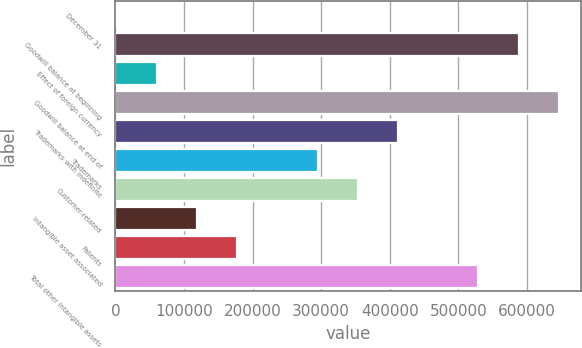<chart> <loc_0><loc_0><loc_500><loc_500><bar_chart><fcel>December 31<fcel>Goodwill balance at beginning<fcel>Effect of foreign currency<fcel>Goodwill balance at end of<fcel>Trademarks with indefinite<fcel>Trademarks<fcel>Customer-related<fcel>Intangible asset associated<fcel>Patents<fcel>Total other intangible assets<nl><fcel>2012<fcel>588003<fcel>60611.1<fcel>646602<fcel>412206<fcel>295008<fcel>353607<fcel>119210<fcel>177809<fcel>529404<nl></chart> 